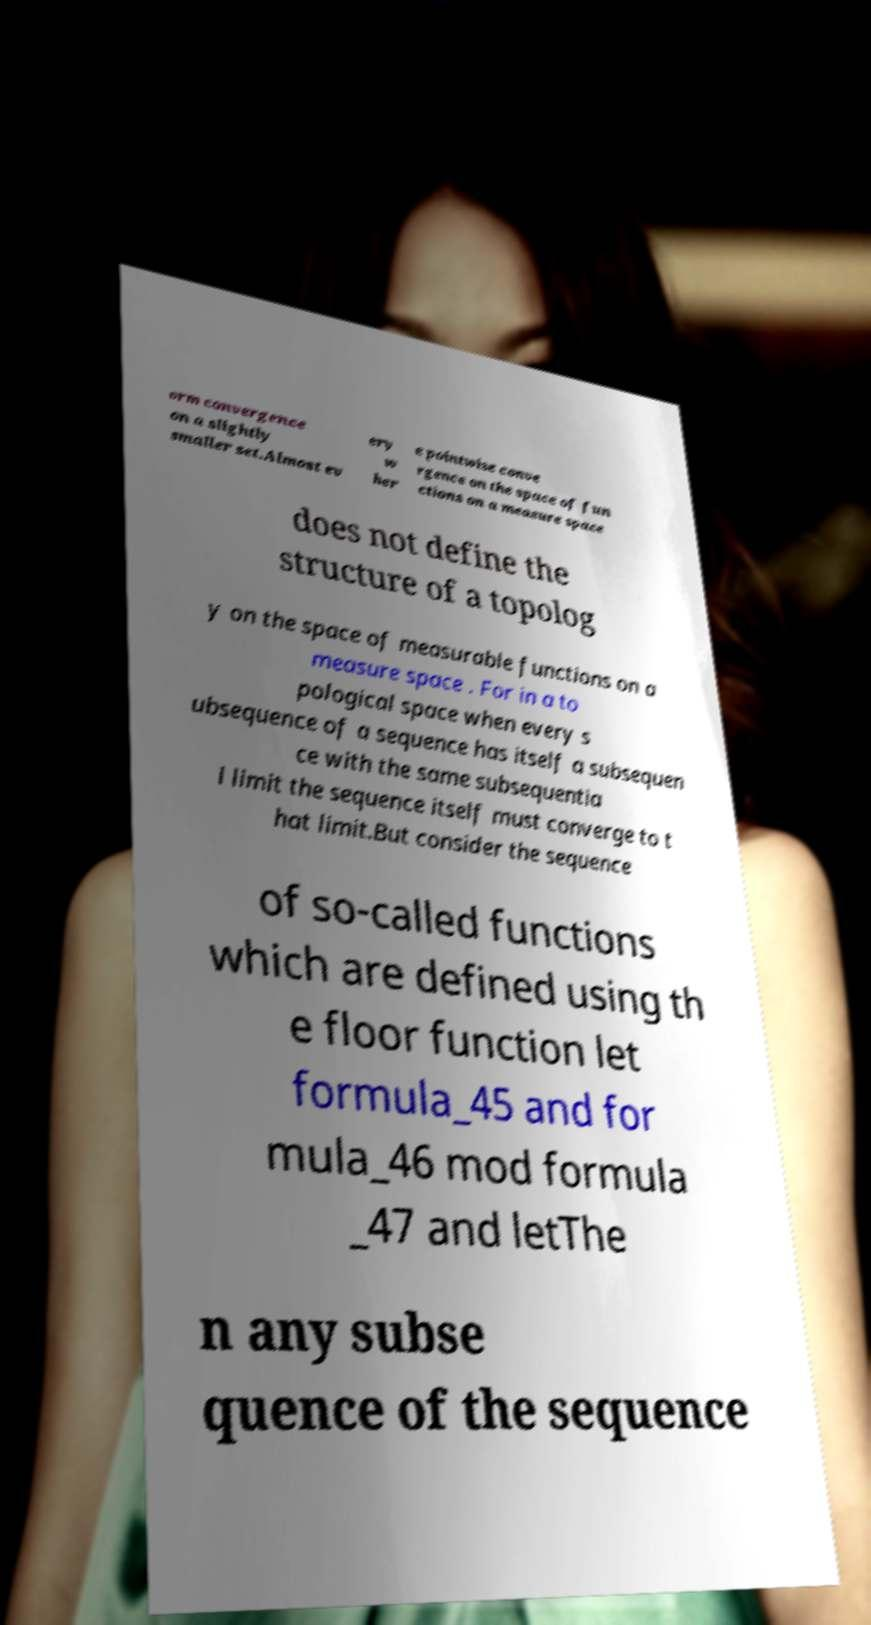Please identify and transcribe the text found in this image. orm convergence on a slightly smaller set.Almost ev ery w her e pointwise conve rgence on the space of fun ctions on a measure space does not define the structure of a topolog y on the space of measurable functions on a measure space . For in a to pological space when every s ubsequence of a sequence has itself a subsequen ce with the same subsequentia l limit the sequence itself must converge to t hat limit.But consider the sequence of so-called functions which are defined using th e floor function let formula_45 and for mula_46 mod formula _47 and letThe n any subse quence of the sequence 